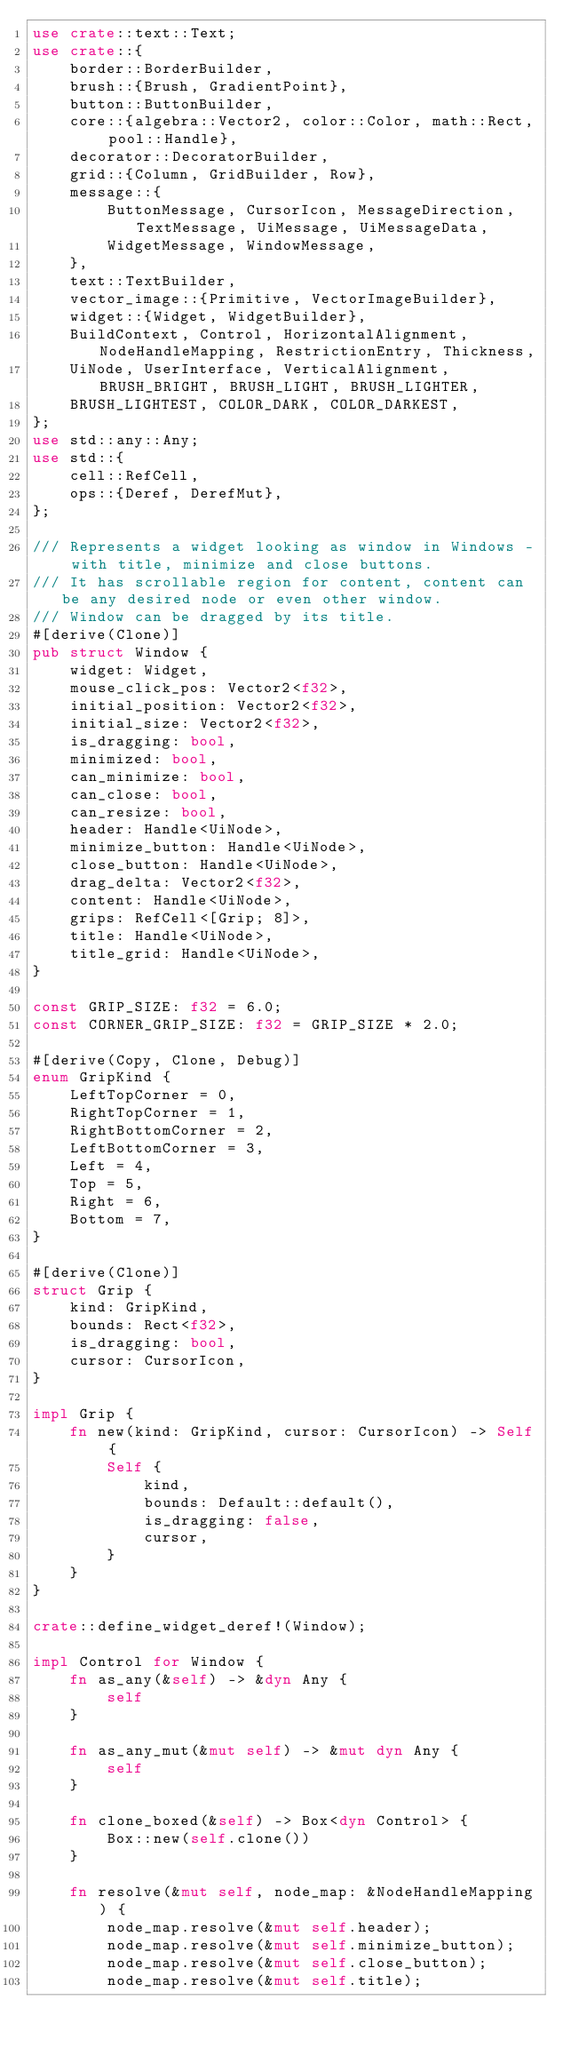Convert code to text. <code><loc_0><loc_0><loc_500><loc_500><_Rust_>use crate::text::Text;
use crate::{
    border::BorderBuilder,
    brush::{Brush, GradientPoint},
    button::ButtonBuilder,
    core::{algebra::Vector2, color::Color, math::Rect, pool::Handle},
    decorator::DecoratorBuilder,
    grid::{Column, GridBuilder, Row},
    message::{
        ButtonMessage, CursorIcon, MessageDirection, TextMessage, UiMessage, UiMessageData,
        WidgetMessage, WindowMessage,
    },
    text::TextBuilder,
    vector_image::{Primitive, VectorImageBuilder},
    widget::{Widget, WidgetBuilder},
    BuildContext, Control, HorizontalAlignment, NodeHandleMapping, RestrictionEntry, Thickness,
    UiNode, UserInterface, VerticalAlignment, BRUSH_BRIGHT, BRUSH_LIGHT, BRUSH_LIGHTER,
    BRUSH_LIGHTEST, COLOR_DARK, COLOR_DARKEST,
};
use std::any::Any;
use std::{
    cell::RefCell,
    ops::{Deref, DerefMut},
};

/// Represents a widget looking as window in Windows - with title, minimize and close buttons.
/// It has scrollable region for content, content can be any desired node or even other window.
/// Window can be dragged by its title.
#[derive(Clone)]
pub struct Window {
    widget: Widget,
    mouse_click_pos: Vector2<f32>,
    initial_position: Vector2<f32>,
    initial_size: Vector2<f32>,
    is_dragging: bool,
    minimized: bool,
    can_minimize: bool,
    can_close: bool,
    can_resize: bool,
    header: Handle<UiNode>,
    minimize_button: Handle<UiNode>,
    close_button: Handle<UiNode>,
    drag_delta: Vector2<f32>,
    content: Handle<UiNode>,
    grips: RefCell<[Grip; 8]>,
    title: Handle<UiNode>,
    title_grid: Handle<UiNode>,
}

const GRIP_SIZE: f32 = 6.0;
const CORNER_GRIP_SIZE: f32 = GRIP_SIZE * 2.0;

#[derive(Copy, Clone, Debug)]
enum GripKind {
    LeftTopCorner = 0,
    RightTopCorner = 1,
    RightBottomCorner = 2,
    LeftBottomCorner = 3,
    Left = 4,
    Top = 5,
    Right = 6,
    Bottom = 7,
}

#[derive(Clone)]
struct Grip {
    kind: GripKind,
    bounds: Rect<f32>,
    is_dragging: bool,
    cursor: CursorIcon,
}

impl Grip {
    fn new(kind: GripKind, cursor: CursorIcon) -> Self {
        Self {
            kind,
            bounds: Default::default(),
            is_dragging: false,
            cursor,
        }
    }
}

crate::define_widget_deref!(Window);

impl Control for Window {
    fn as_any(&self) -> &dyn Any {
        self
    }

    fn as_any_mut(&mut self) -> &mut dyn Any {
        self
    }

    fn clone_boxed(&self) -> Box<dyn Control> {
        Box::new(self.clone())
    }

    fn resolve(&mut self, node_map: &NodeHandleMapping) {
        node_map.resolve(&mut self.header);
        node_map.resolve(&mut self.minimize_button);
        node_map.resolve(&mut self.close_button);
        node_map.resolve(&mut self.title);</code> 